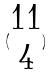<formula> <loc_0><loc_0><loc_500><loc_500>( \begin{matrix} 1 1 \\ 4 \end{matrix} )</formula> 